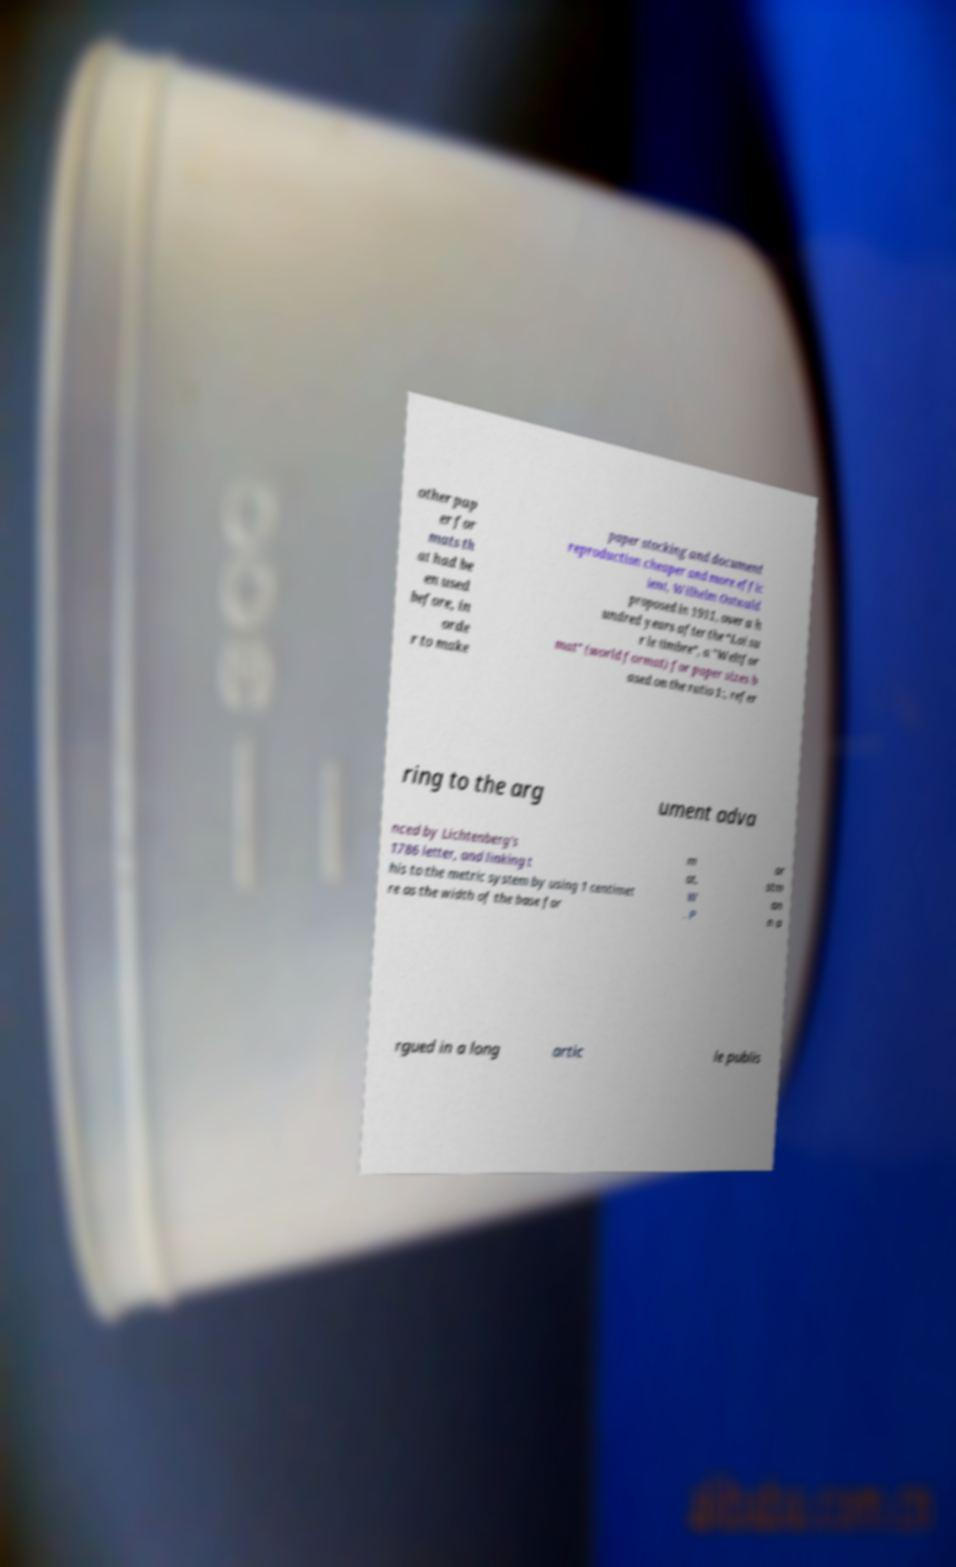Can you read and provide the text displayed in the image?This photo seems to have some interesting text. Can you extract and type it out for me? other pap er for mats th at had be en used before, in orde r to make paper stocking and document reproduction cheaper and more effic ient, Wilhelm Ostwald proposed in 1911, over a h undred years after the “Loi su r le timbre”, a "Weltfor mat" (world format) for paper sizes b ased on the ratio 1:, refer ring to the arg ument adva nced by Lichtenberg's 1786 letter, and linking t his to the metric system by using 1 centimet re as the width of the base for m at. W . P or stm an n a rgued in a long artic le publis 